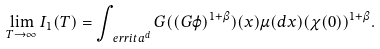Convert formula to latex. <formula><loc_0><loc_0><loc_500><loc_500>\lim _ { T \to \infty } I _ { 1 } ( T ) = \int _ { \ e r r i t a ^ { d } } G ( ( G \varphi ) ^ { 1 + \beta } ) ( x ) \mu ( d x ) ( \chi ( 0 ) ) ^ { 1 + \beta } .</formula> 